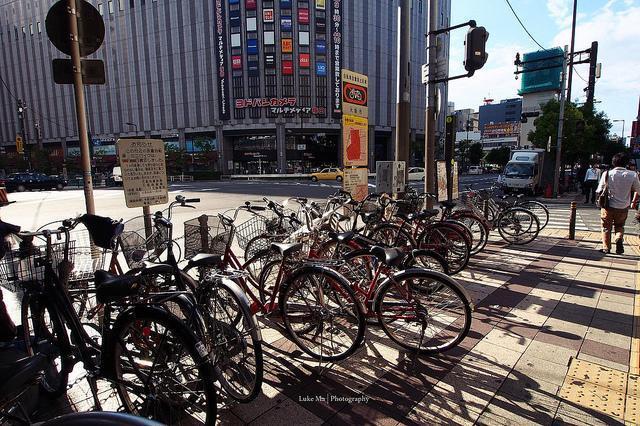Where are the owners of these bikes while this photo was taken?
Indicate the correct response by choosing from the four available options to answer the question.
Options: At work, overseas, skydiving, home. At work. 